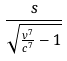<formula> <loc_0><loc_0><loc_500><loc_500>\frac { s } { \sqrt { \frac { v ^ { 7 } } { c ^ { 7 } } - 1 } }</formula> 